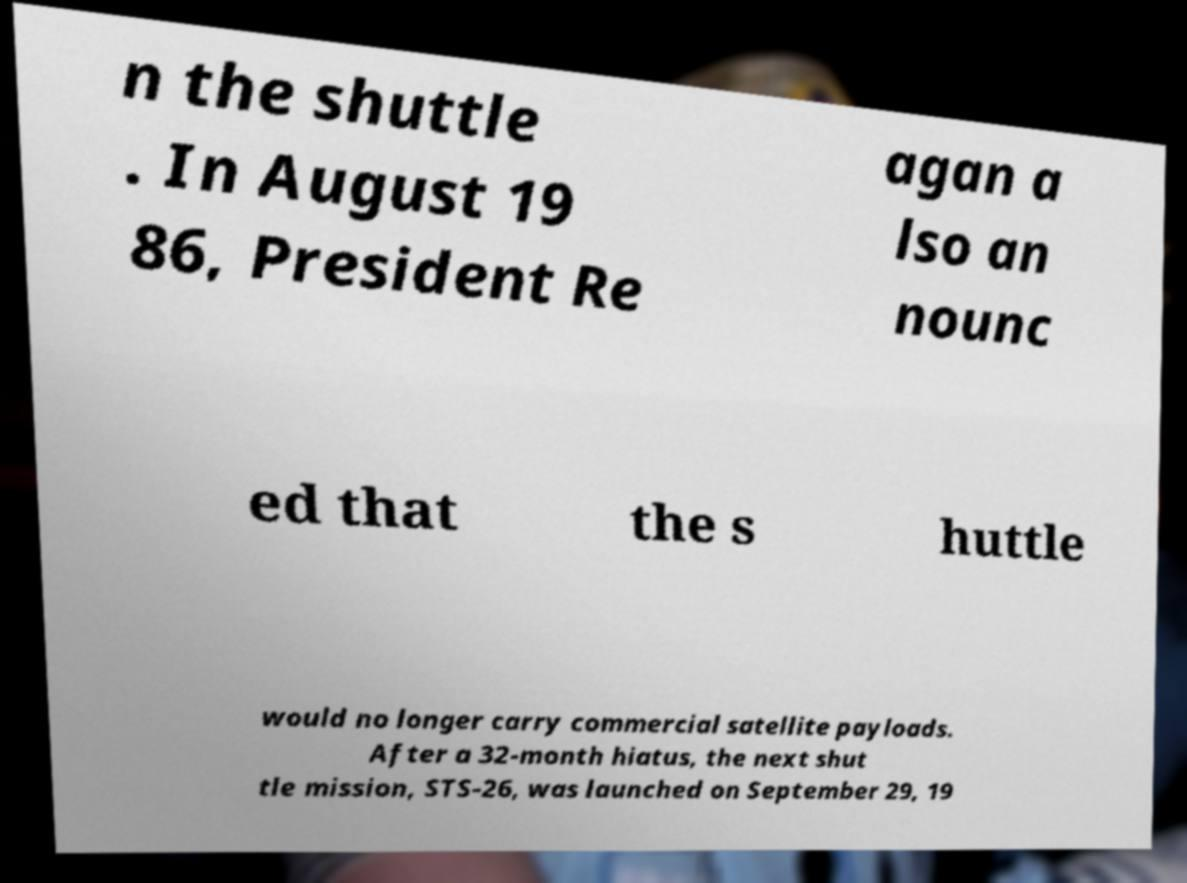Can you read and provide the text displayed in the image?This photo seems to have some interesting text. Can you extract and type it out for me? n the shuttle . In August 19 86, President Re agan a lso an nounc ed that the s huttle would no longer carry commercial satellite payloads. After a 32-month hiatus, the next shut tle mission, STS-26, was launched on September 29, 19 